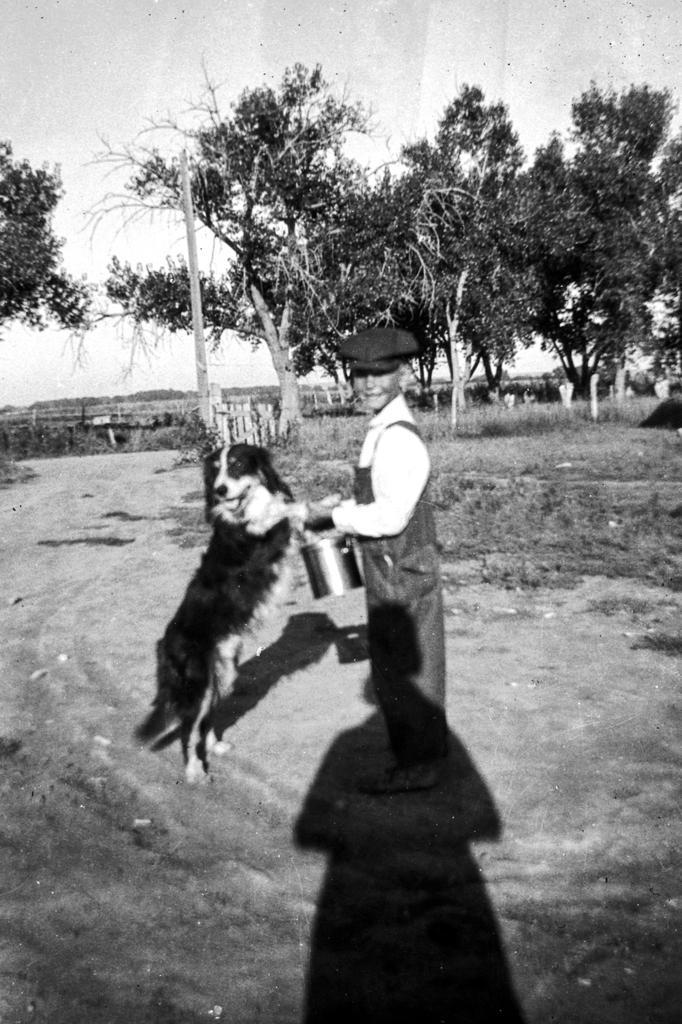In one or two sentences, can you explain what this image depicts? This is a black and white image. In the center of the image there is a boy. There is a dog. At the bottom of the image there is ground. In the background of the image there are trees. At the top of the image there is sky. 